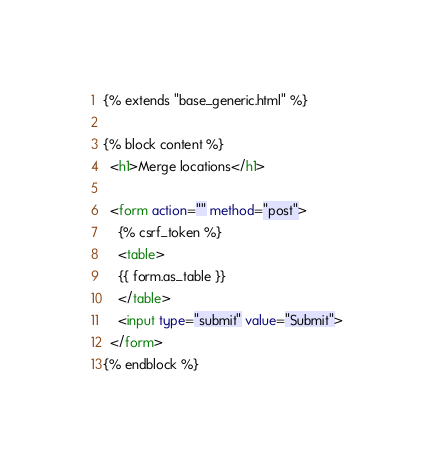Convert code to text. <code><loc_0><loc_0><loc_500><loc_500><_HTML_>{% extends "base_generic.html" %}

{% block content %}
  <h1>Merge locations</h1>

  <form action="" method="post">
    {% csrf_token %}
    <table>
    {{ form.as_table }}
    </table>
    <input type="submit" value="Submit">
  </form>
{% endblock %}</code> 